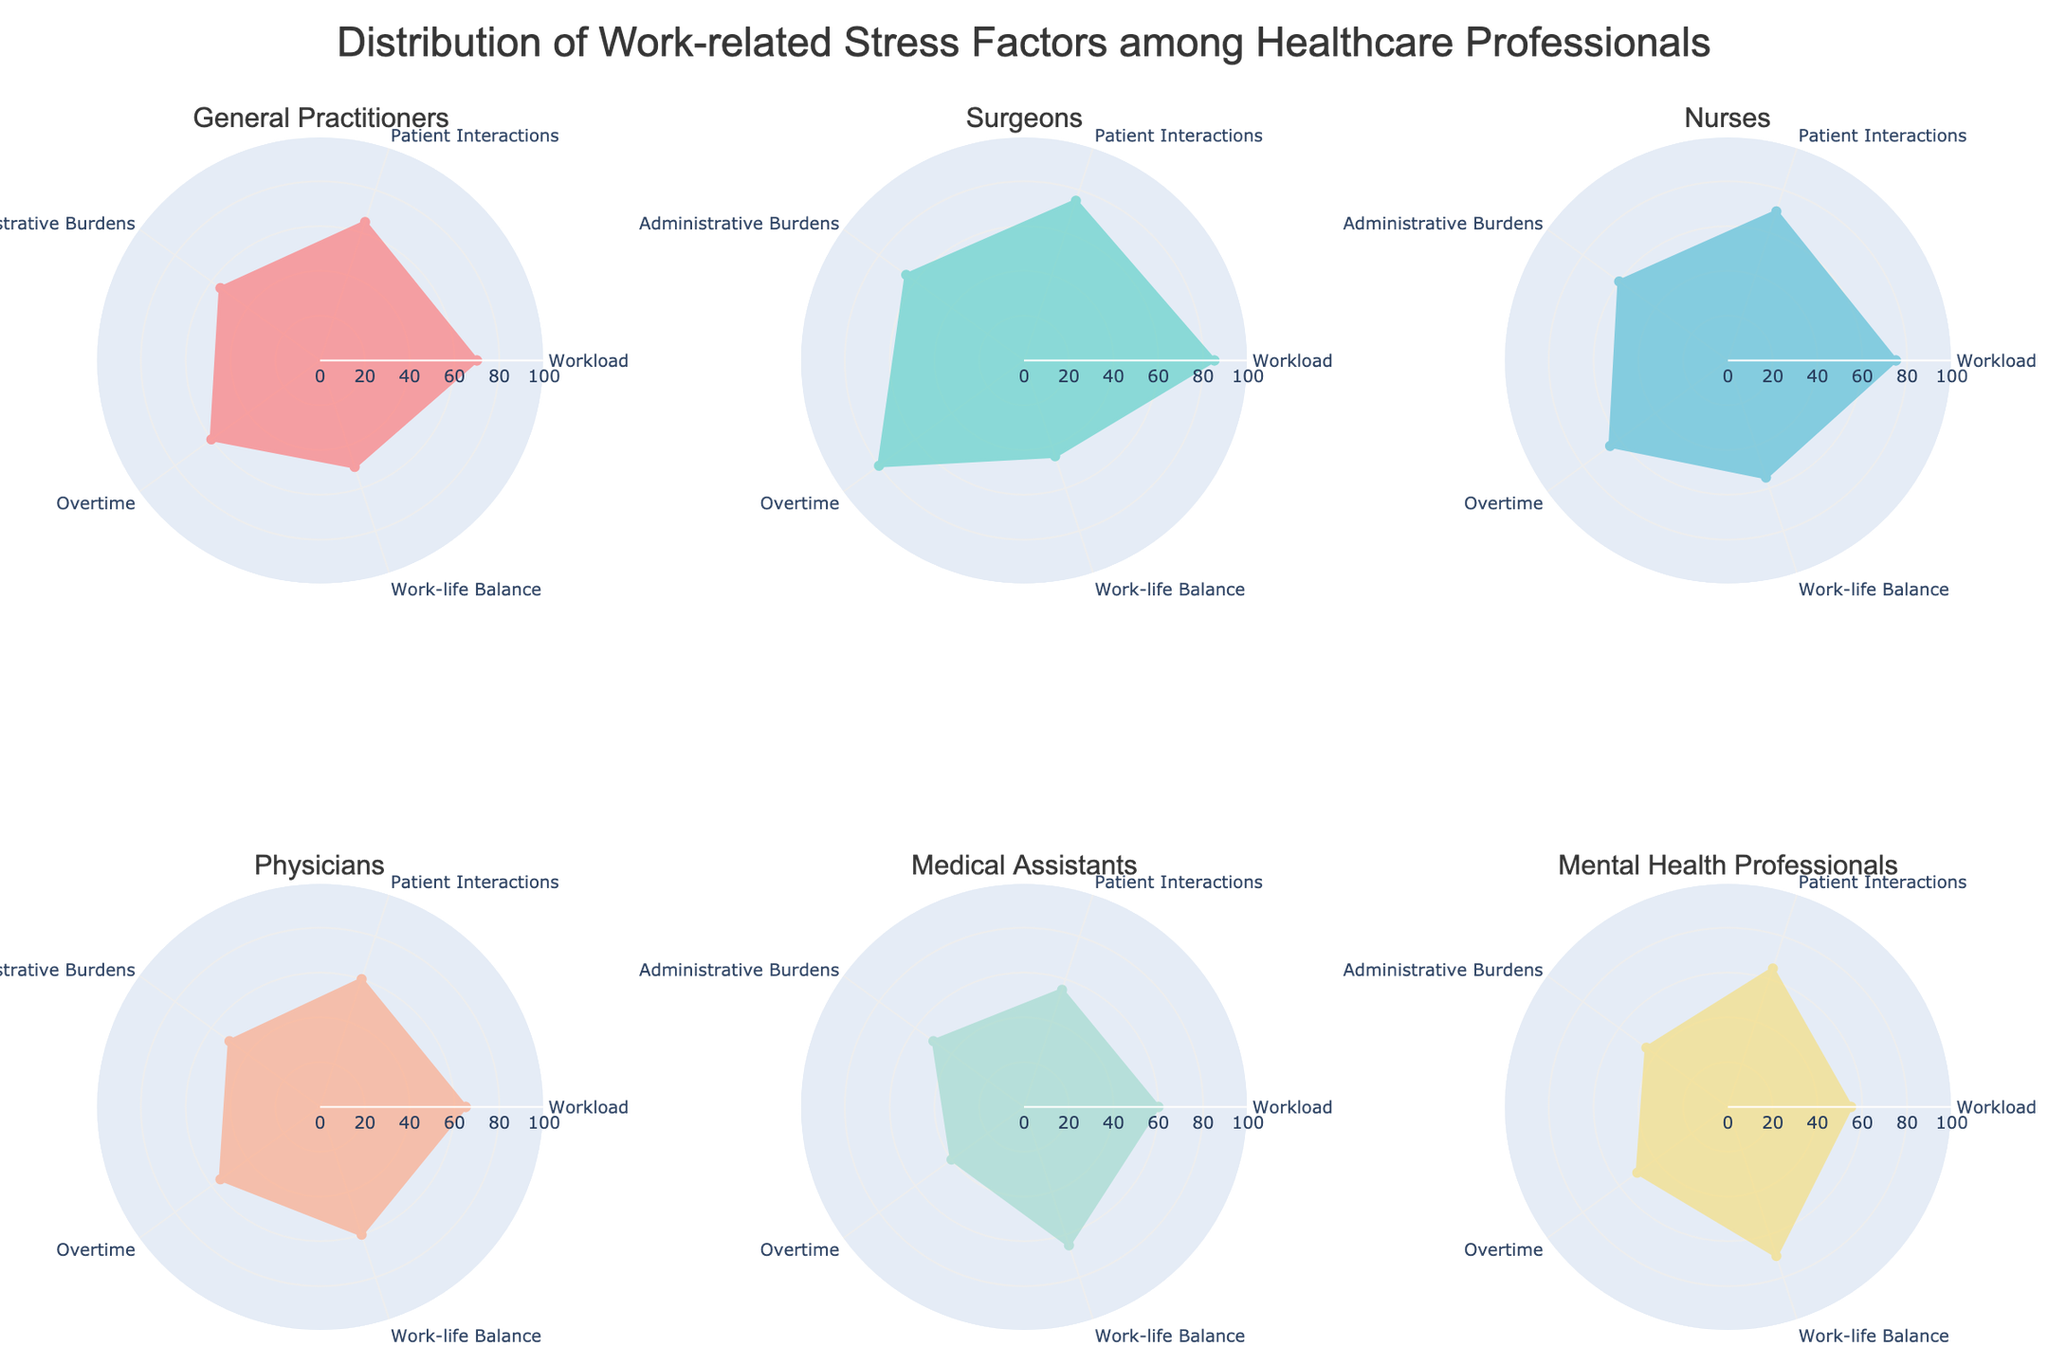Which category has the highest workload stress factor? Looking at the radar chart, the category with the highest value at the "Workload" axis is "Surgeons," with a value of 85.
Answer: Surgeons Which healthcare category has the lowest overtime stress factor? On the overtime axis, the lowest value is for "Medical Assistants," which is 40.
Answer: Medical Assistants What is the median value for work-life balance among all categories? To find the median, list the work-life balance values in order: 45, 50, 55, 60, 65, 70. The median is the average of the 3rd and 4th values: (55 + 60) / 2 = 57.5.
Answer: 57.5 Which category has a higher level of stress in patient interactions compared to workload? Comparing patient interactions and workload values for each category, only "Mental Health Professionals" have a higher patient interactions value (65) compared to workload (55).
Answer: Mental Health Professionals Which two categories have an equal stress level for administrative burdens? Check the administrative burdens axis for equal values; both "Physicians" and "Medical Assistants" have a value of 50.
Answer: Physicians and Medical Assistants Which category shows the most balanced stress distribution across all factors? A balanced distribution means values are relatively close to each other. "Medical Assistants" have a spread of values ranging from 40 to 65, which is one of the smallest ranges.
Answer: Medical Assistants What is the total stress score (sum of all factors) for Nurses? Adding the values for Nurses: 75 (Workload) + 70 (Patient Interactions) + 60 (Administrative Burdens) + 65 (Overtime) + 55 (Work-life Balance) = 325.
Answer: 325 Among General Practitioners, Surgeons, and Nurses, which category has the lowest average stress factor value? Calculate the averages: General Practitioners (70+65+55+60+50)/5 = 60, Surgeons (85+75+65+80+45)/5 = 70, Nurses (75+70+60+65+55)/5 = 65. The lowest average is for General Practitioners.
Answer: General Practitioners How does the work-life balance stress factor for Nurses compare to that for General Practitioners? Nurses have a work-life balance score of 55, while General Practitioners have 50, meaning Nurses have a higher work-life balance score by 5 points.
Answer: Nurses are 5 points higher 